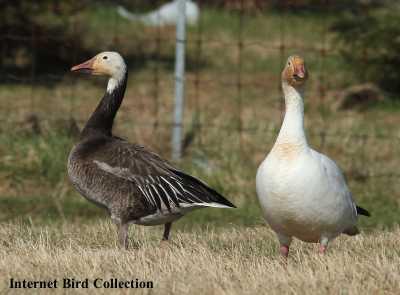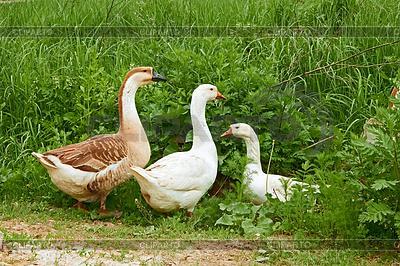The first image is the image on the left, the second image is the image on the right. For the images displayed, is the sentence "There are two geese with their beaks pressed together in one of the images." factually correct? Answer yes or no. No. The first image is the image on the left, the second image is the image on the right. Considering the images on both sides, is "geese are facing each other and touching beaks" valid? Answer yes or no. No. 